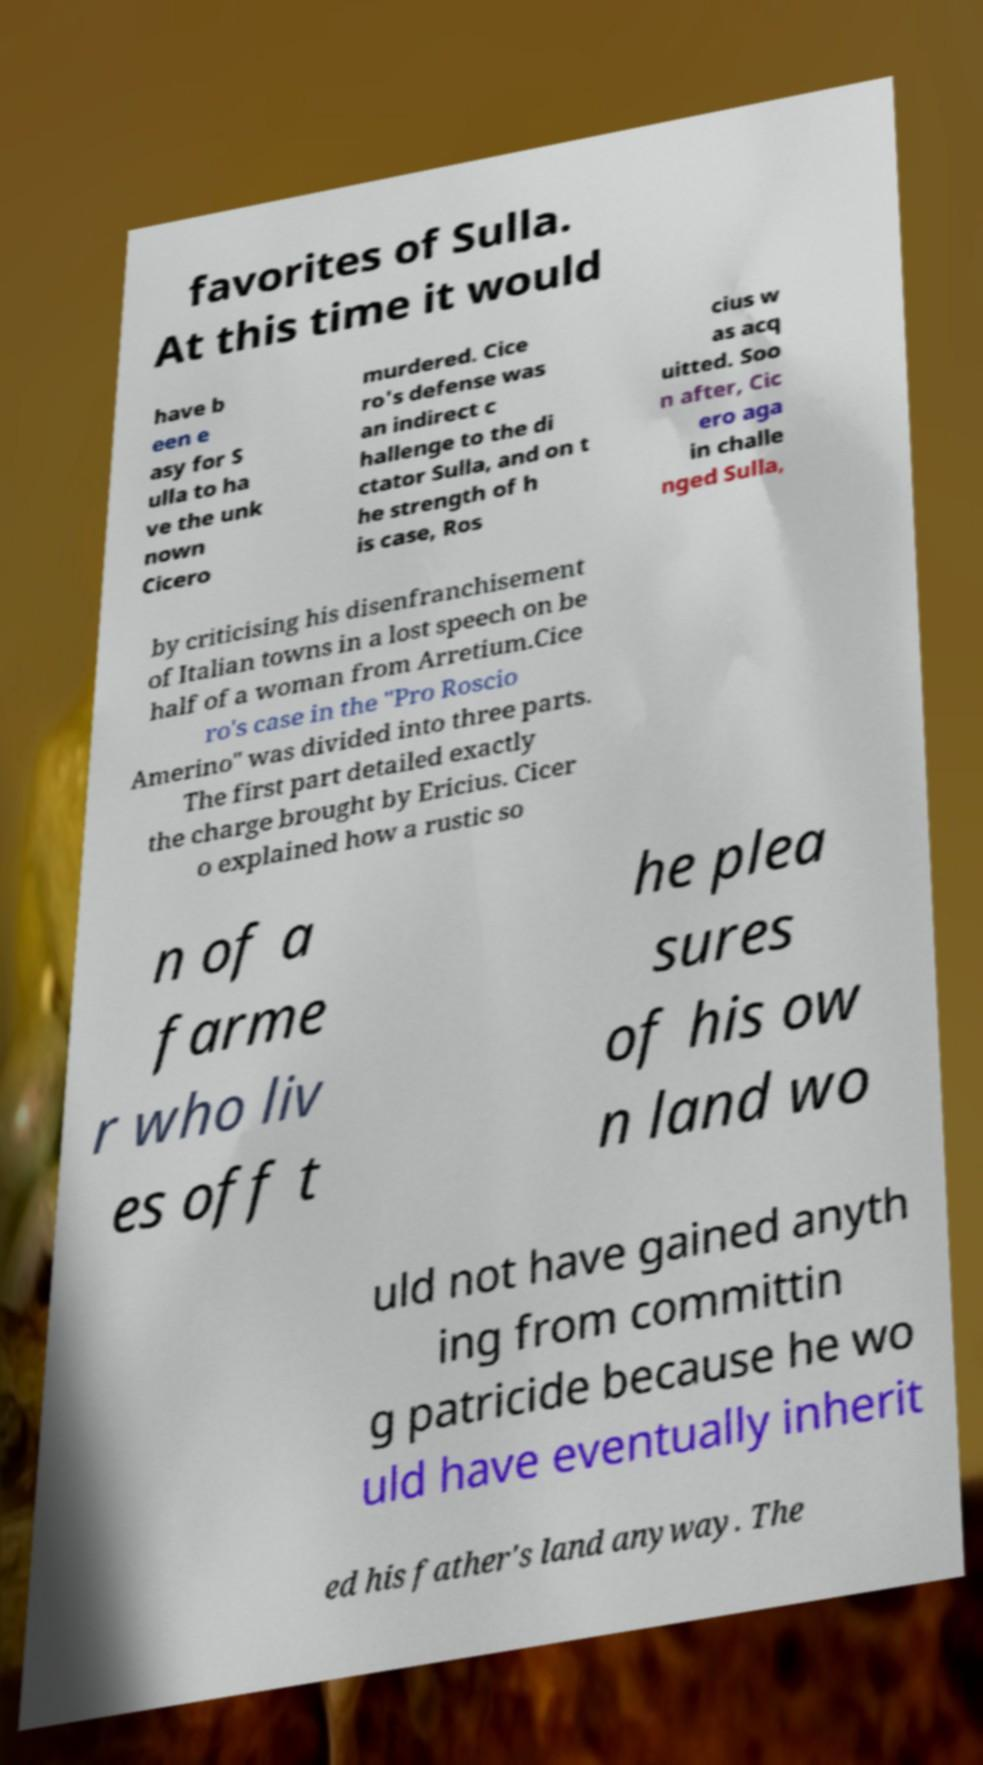I need the written content from this picture converted into text. Can you do that? favorites of Sulla. At this time it would have b een e asy for S ulla to ha ve the unk nown Cicero murdered. Cice ro's defense was an indirect c hallenge to the di ctator Sulla, and on t he strength of h is case, Ros cius w as acq uitted. Soo n after, Cic ero aga in challe nged Sulla, by criticising his disenfranchisement of Italian towns in a lost speech on be half of a woman from Arretium.Cice ro's case in the "Pro Roscio Amerino" was divided into three parts. The first part detailed exactly the charge brought by Ericius. Cicer o explained how a rustic so n of a farme r who liv es off t he plea sures of his ow n land wo uld not have gained anyth ing from committin g patricide because he wo uld have eventually inherit ed his father's land anyway. The 